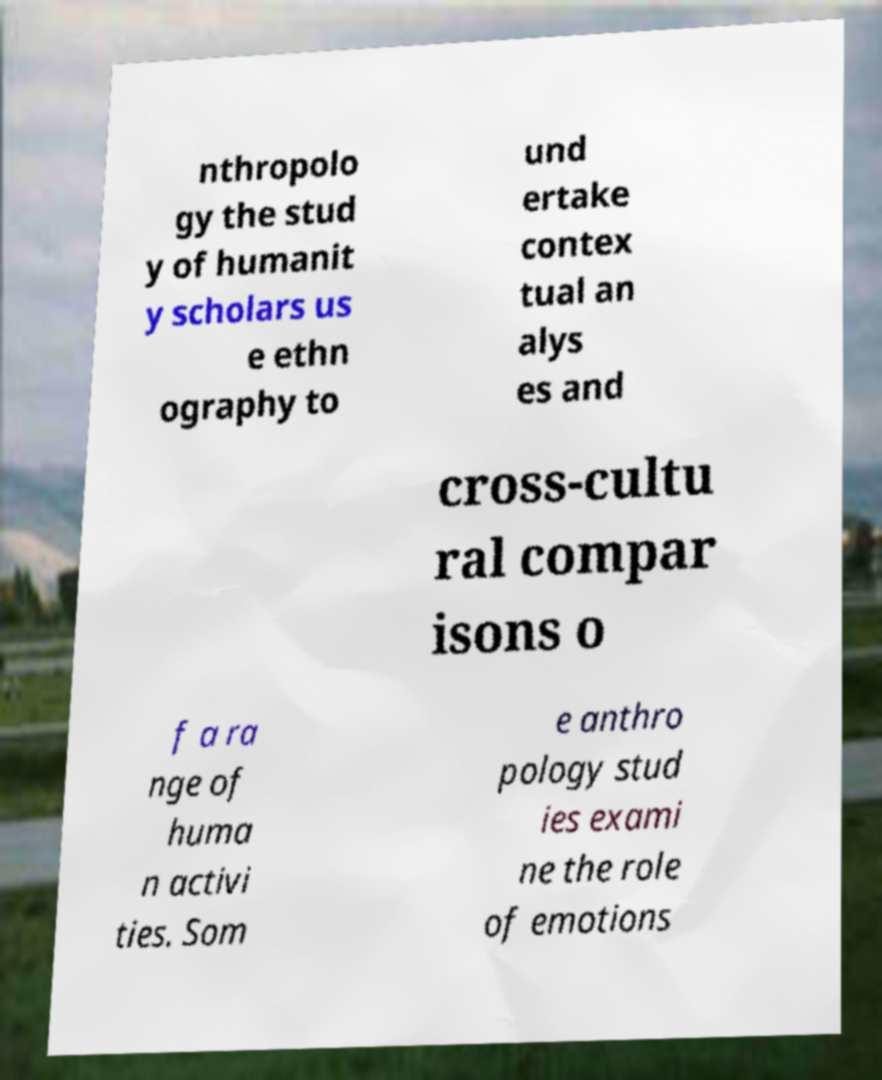Please read and relay the text visible in this image. What does it say? nthropolo gy the stud y of humanit y scholars us e ethn ography to und ertake contex tual an alys es and cross-cultu ral compar isons o f a ra nge of huma n activi ties. Som e anthro pology stud ies exami ne the role of emotions 